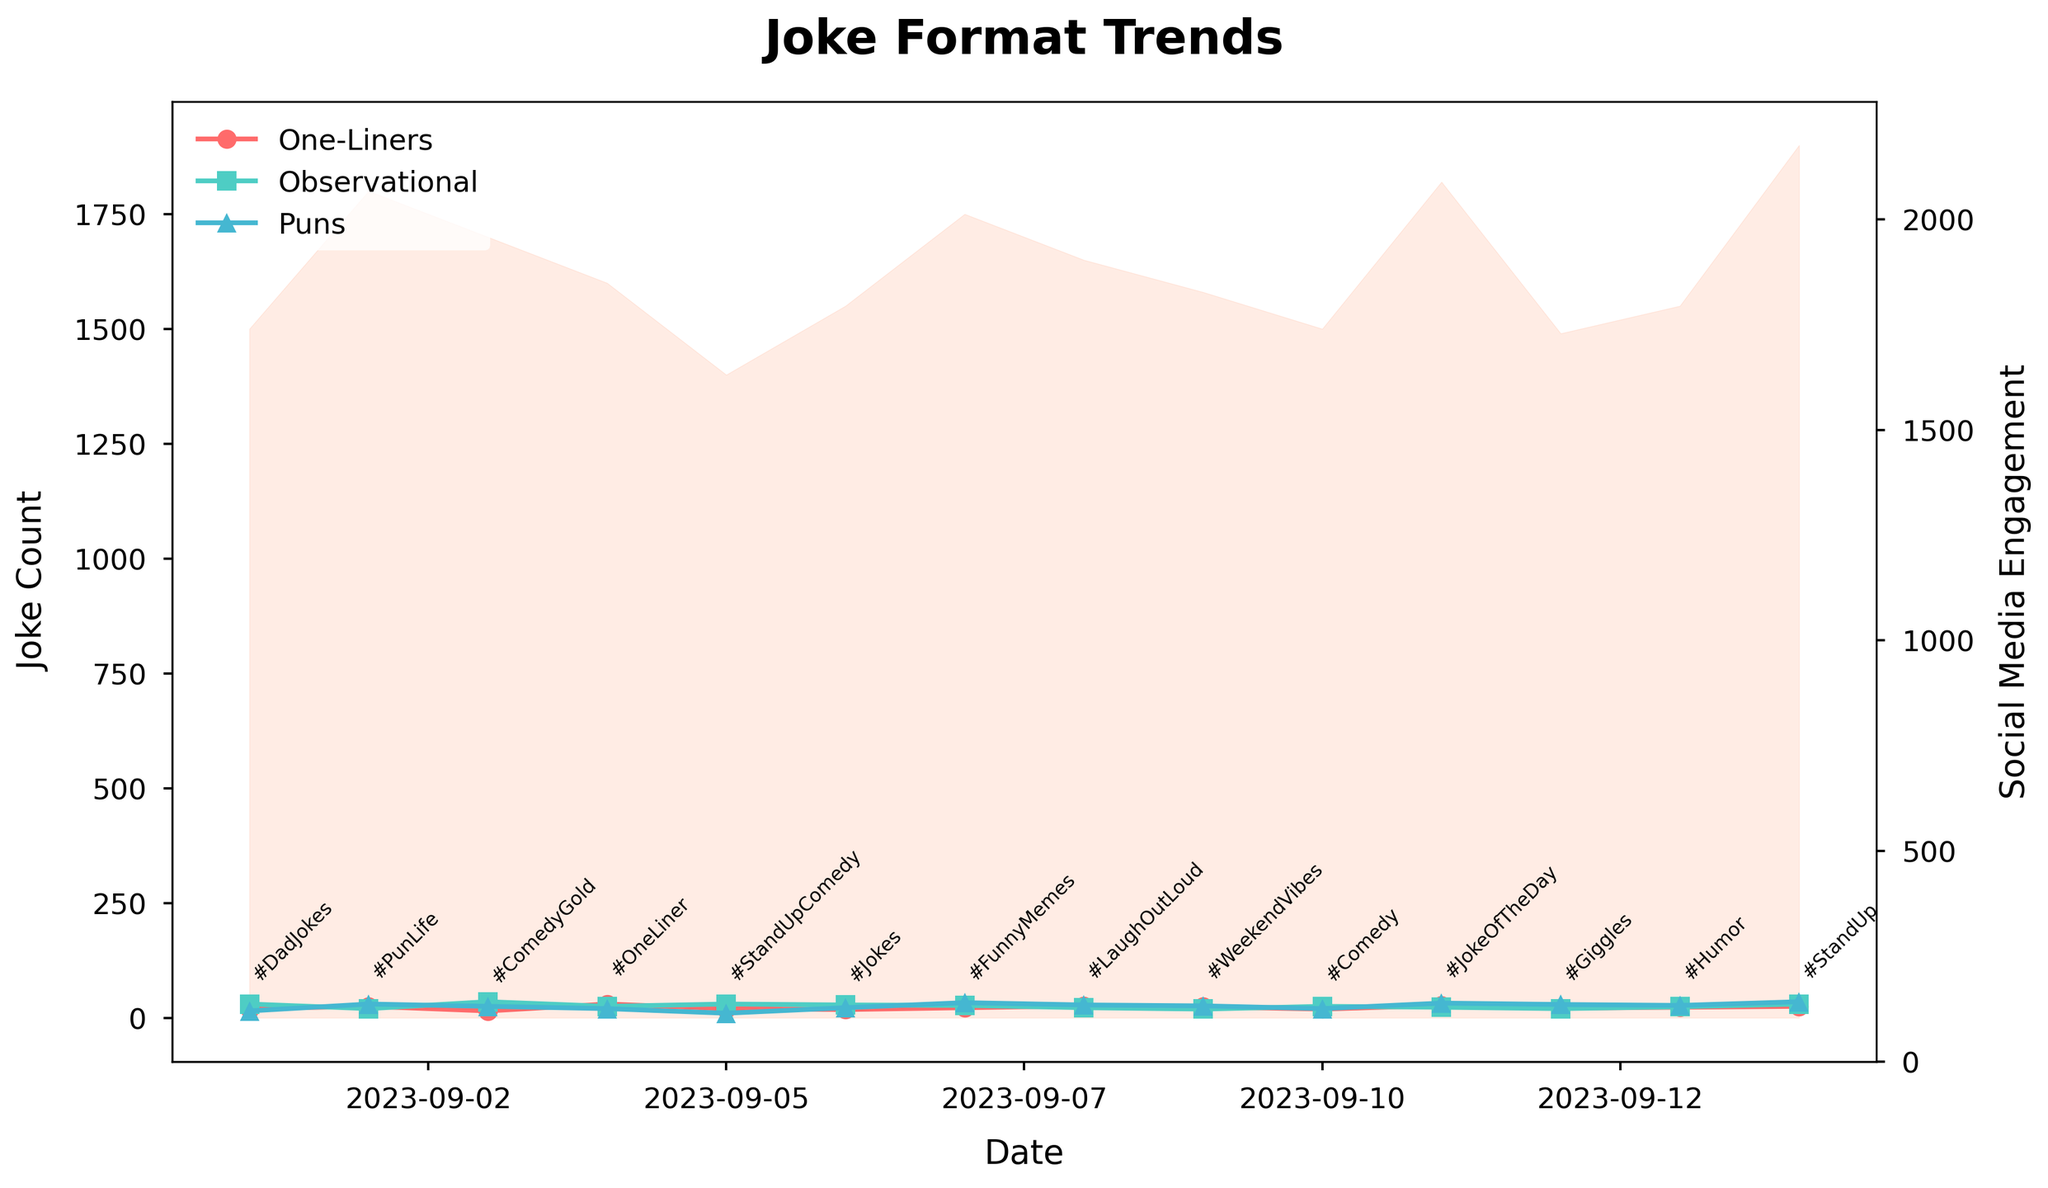What is the title of the plot? The title of the plot is usually displayed at the top of the figure in a larger, bold font. Here it reads "Joke Format Trends".
Answer: Joke Format Trends How many different joke types are shown in the plot? By examining the legend or the lines in the plot, we see three different joke types, each represented by different lines and markers. These are One-Liners, Observational Jokes, and Puns.
Answer: 3 What colors represent One-Liners and Puns? Colors for the joke types can be identified in the legend. One-Liners are represented by a reddish line, and Puns are represented by a bluish line.
Answer: Reddish for One-Liners and Bluish for Puns Which day has the highest count of Observational jokes? Observing the line with square markers (representing Observational Jokes) across the dates, we see that the highest peak happens on 2023-09-03.
Answer: 2023-09-03 What is the social media engagement on 2023-09-14? The social media engagement is represented by the shaded area on the plot. By looking at the height of the shading on 2023-09-14, we can deduce it hits 1900.
Answer: 1900 What trends can you observe about the counts of One-Liner Jokes and Puns over the date range? By comparing the two lines, we see that One-Liner Jokes have peaks on 2023-09-04 and 2023-09-11, while counts of Puns increase noticeably towards 2023-09-14.
Answer: One-Liner Jokes peak on 2023-09-04 and 2023-09-11, Puns increase towards 2023-09-14 Which hashtag appears on the day with the lowest social media engagement observed? By observing the fill area for low points in engagement and matching that with the annotations, the hashtag on 2023-09-12 with an engagement of 1490 is "#Giggles".
Answer: #Giggles On which dates do One-Liner Jokes and Puns both exceed 25? Refer to the lines representing One-Liner Jokes and Puns and check for dates where both cross the 25 mark. This happens on 2023-09-02, 2023-09-08, 2023-09-11, and 2023-09-14.
Answer: 2023-09-02, 2023-09-08, 2023-09-11, 2023-09-14 How does the count of Observational Jokes on 2023-09-06 compare to that on 2023-09-10? Check the count of Observational Jokes on these dates. This type of joke count is higher on 2023-09-06 than on 2023-09-10 (28 versus 25).
Answer: Higher on 2023-09-06 Which joke format has the highest count on 2023-09-07? By following the lines for each joke format to the value on 2023-09-07, Puns have the highest count at 33.
Answer: Puns 